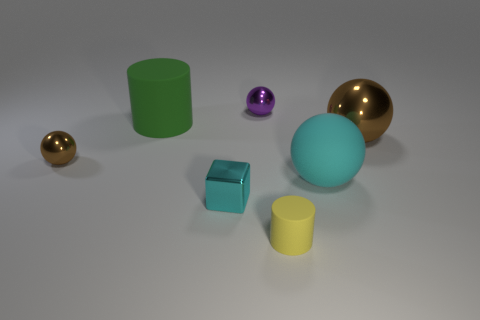What number of large things are either green cylinders or rubber cylinders?
Provide a succinct answer. 1. Is the shape of the small purple thing the same as the big cyan matte thing?
Keep it short and to the point. Yes. How many objects are both on the right side of the large green object and in front of the purple metallic thing?
Offer a terse response. 4. Are there any other things that are the same color as the rubber ball?
Make the answer very short. Yes. There is a small purple object that is made of the same material as the block; what shape is it?
Offer a very short reply. Sphere. Does the purple ball have the same size as the cyan ball?
Ensure brevity in your answer.  No. Does the brown object that is to the left of the green thing have the same material as the cyan cube?
Provide a succinct answer. Yes. Are there any other things that are made of the same material as the tiny purple sphere?
Your answer should be compact. Yes. There is a metallic thing that is behind the metal ball that is on the right side of the yellow matte thing; what number of metallic spheres are to the left of it?
Your response must be concise. 1. Does the large matte thing behind the small brown shiny object have the same shape as the yellow object?
Offer a very short reply. Yes. 